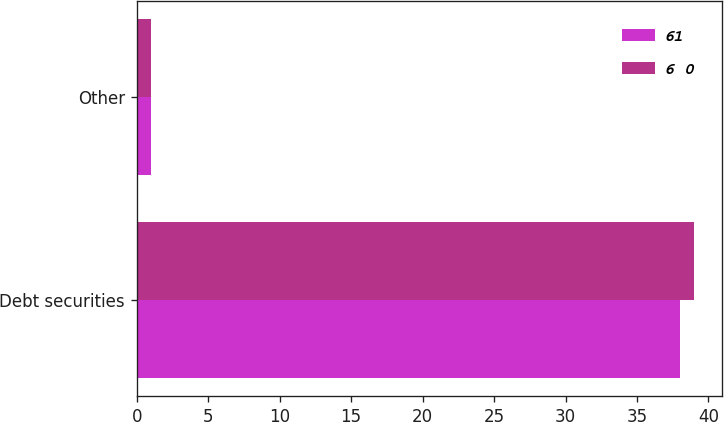Convert chart. <chart><loc_0><loc_0><loc_500><loc_500><stacked_bar_chart><ecel><fcel>Debt securities<fcel>Other<nl><fcel>61<fcel>38<fcel>1<nl><fcel>6 0<fcel>39<fcel>1<nl></chart> 